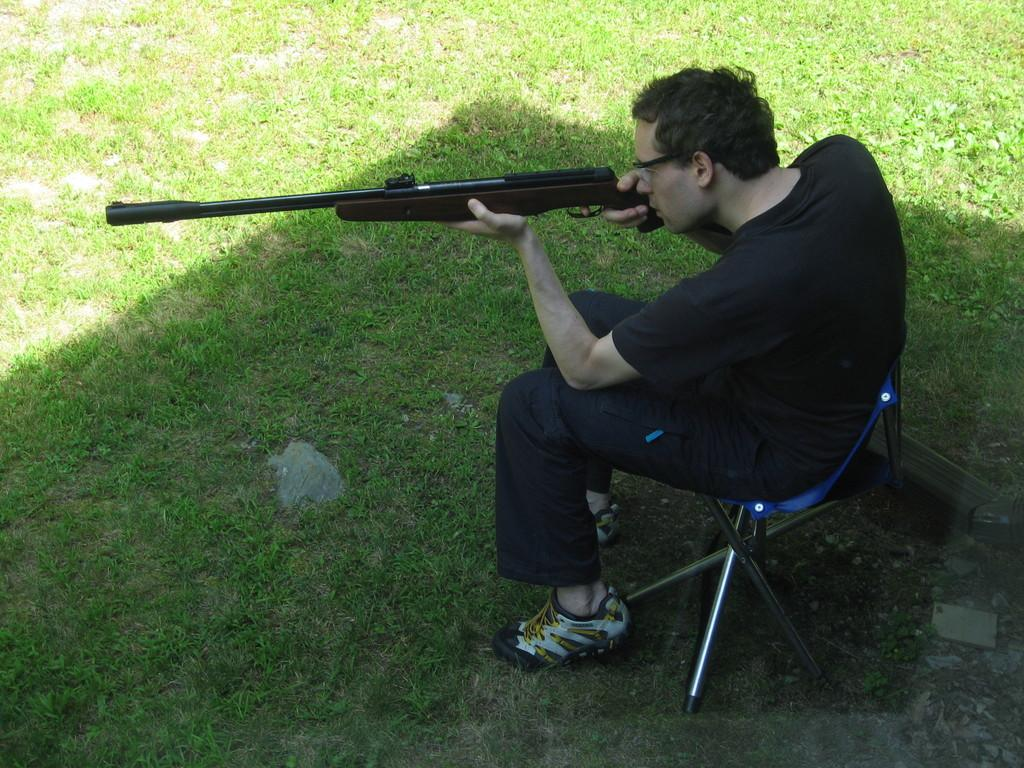What is the person in the image doing? There is a person sitting on a chair in the image. What object is the person holding in his hands? The person is holding a gun in his hands. What type of quilt is being used to cover the person's position in the image? There is no quilt present in the image, and the person's position is not being covered by any object. 